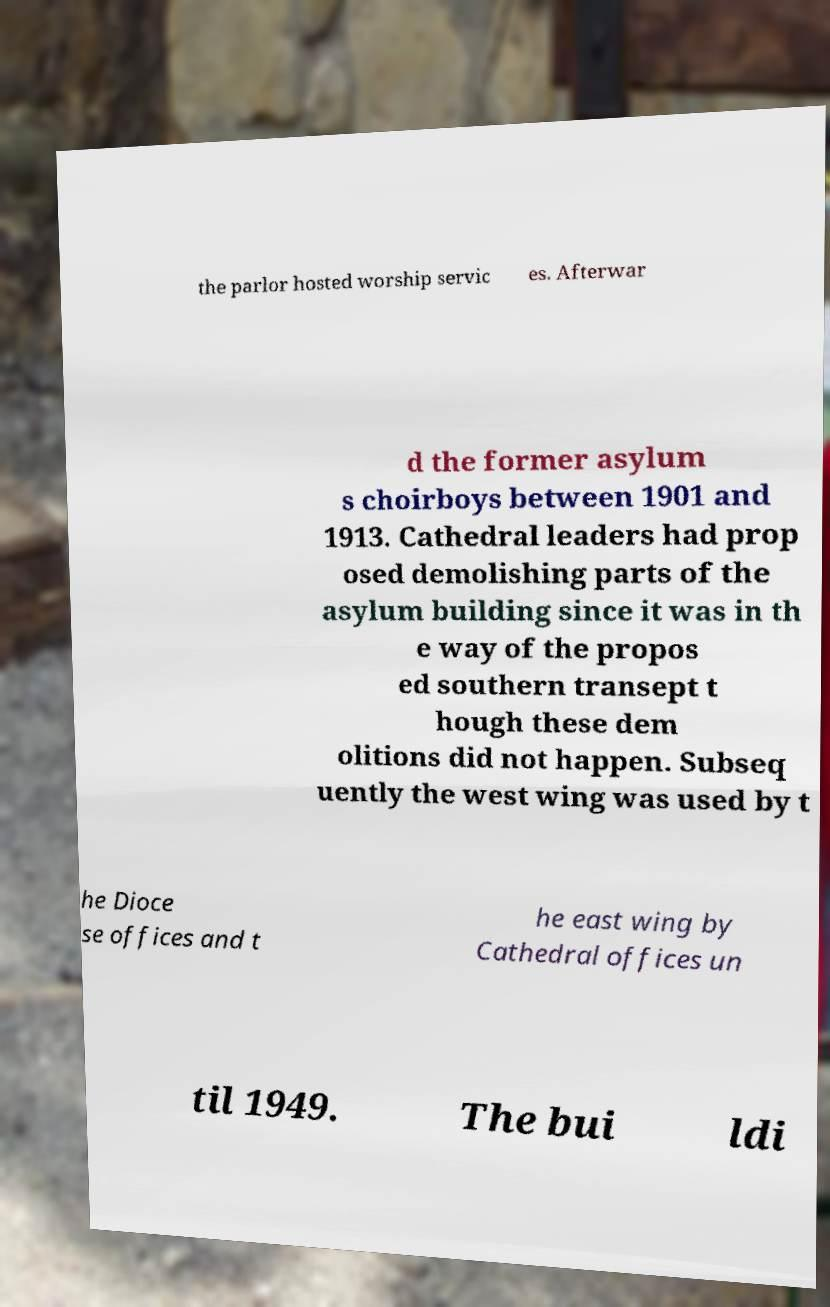Please identify and transcribe the text found in this image. the parlor hosted worship servic es. Afterwar d the former asylum s choirboys between 1901 and 1913. Cathedral leaders had prop osed demolishing parts of the asylum building since it was in th e way of the propos ed southern transept t hough these dem olitions did not happen. Subseq uently the west wing was used by t he Dioce se offices and t he east wing by Cathedral offices un til 1949. The bui ldi 